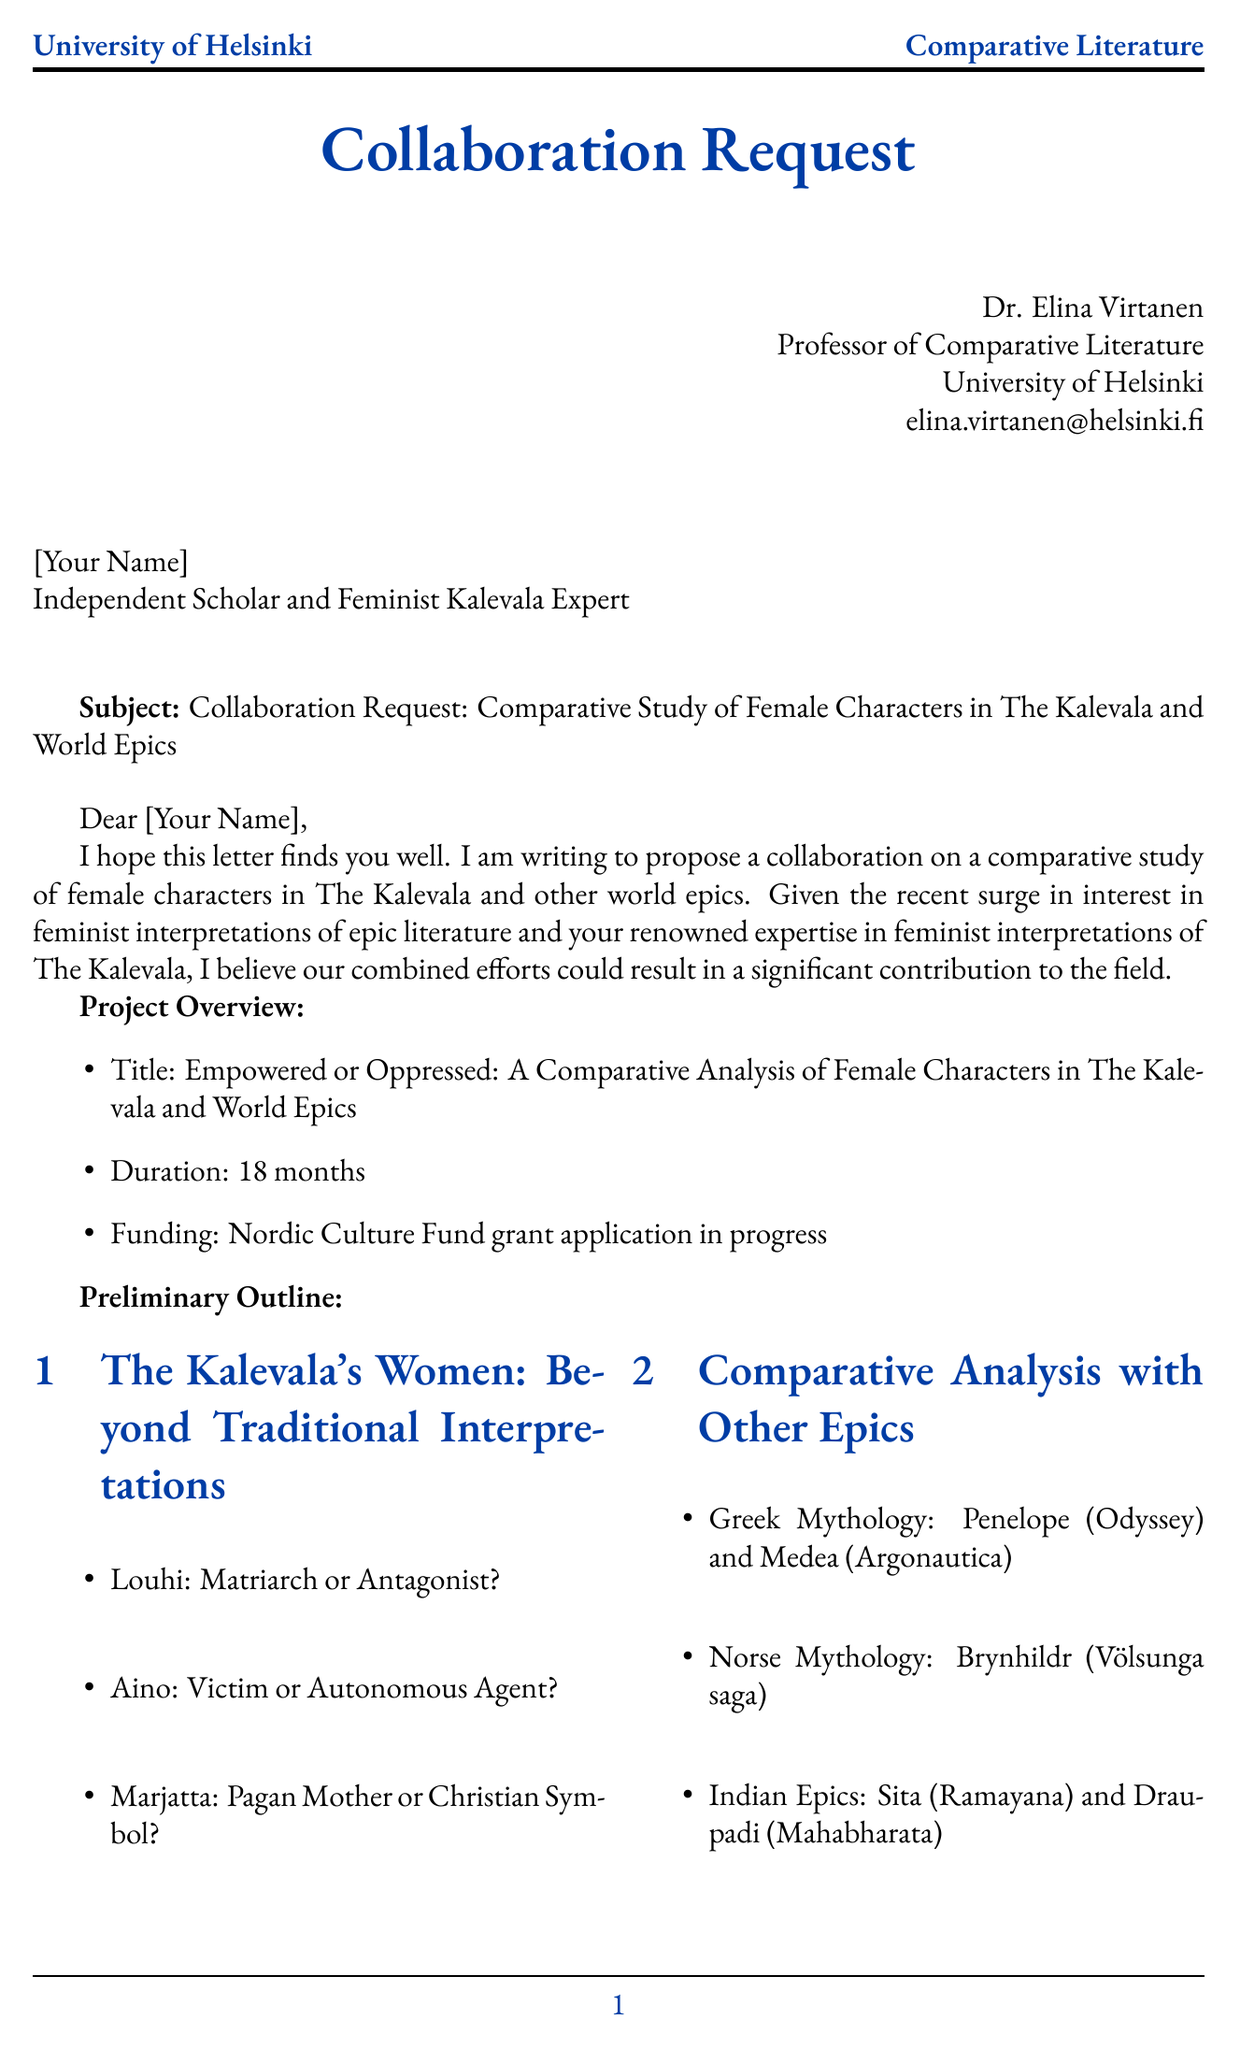What is the sender's title? The sender is introduced with their academic position, which is Professor of Comparative Literature.
Answer: Professor of Comparative Literature What is the primary purpose of the letter? The letter's main goal is to propose a collaboration on a study related to female characters in literature.
Answer: Propose collaboration How long is the projected duration of the project? The letter specifies that the project is expected to last for a specific period.
Answer: 18 months Which feminist character in The Kalevala is referred to as a potential autonomous agent? The outline mentions a character who is analyzed as possibly having autonomy in the context of feminist interpretation.
Answer: Aino What is one suggested benefit of collaboration? The letter lists several advantages of collaboration, including academic publications.
Answer: Publication in a high-impact academic journal What is the title of the project? The letter outlines the name of the comparative study project.
Answer: Empowered or Oppressed What upcoming event is mentioned as a relevant conference? The letter lists events that might relate to the study and networking opportunities.
Answer: Annual Folklore Fellows' Summer School in Turku, Finland What is the first section of the preliminary outline? The outline breaks down the project into specific sections, with the first titled appropriately for its focus.
Answer: The Kalevala's Women: Beyond Traditional Interpretations What is the email address of the sender? Contact information is provided for the sender for further communication.
Answer: elina.virtanen@helsinki.fi 